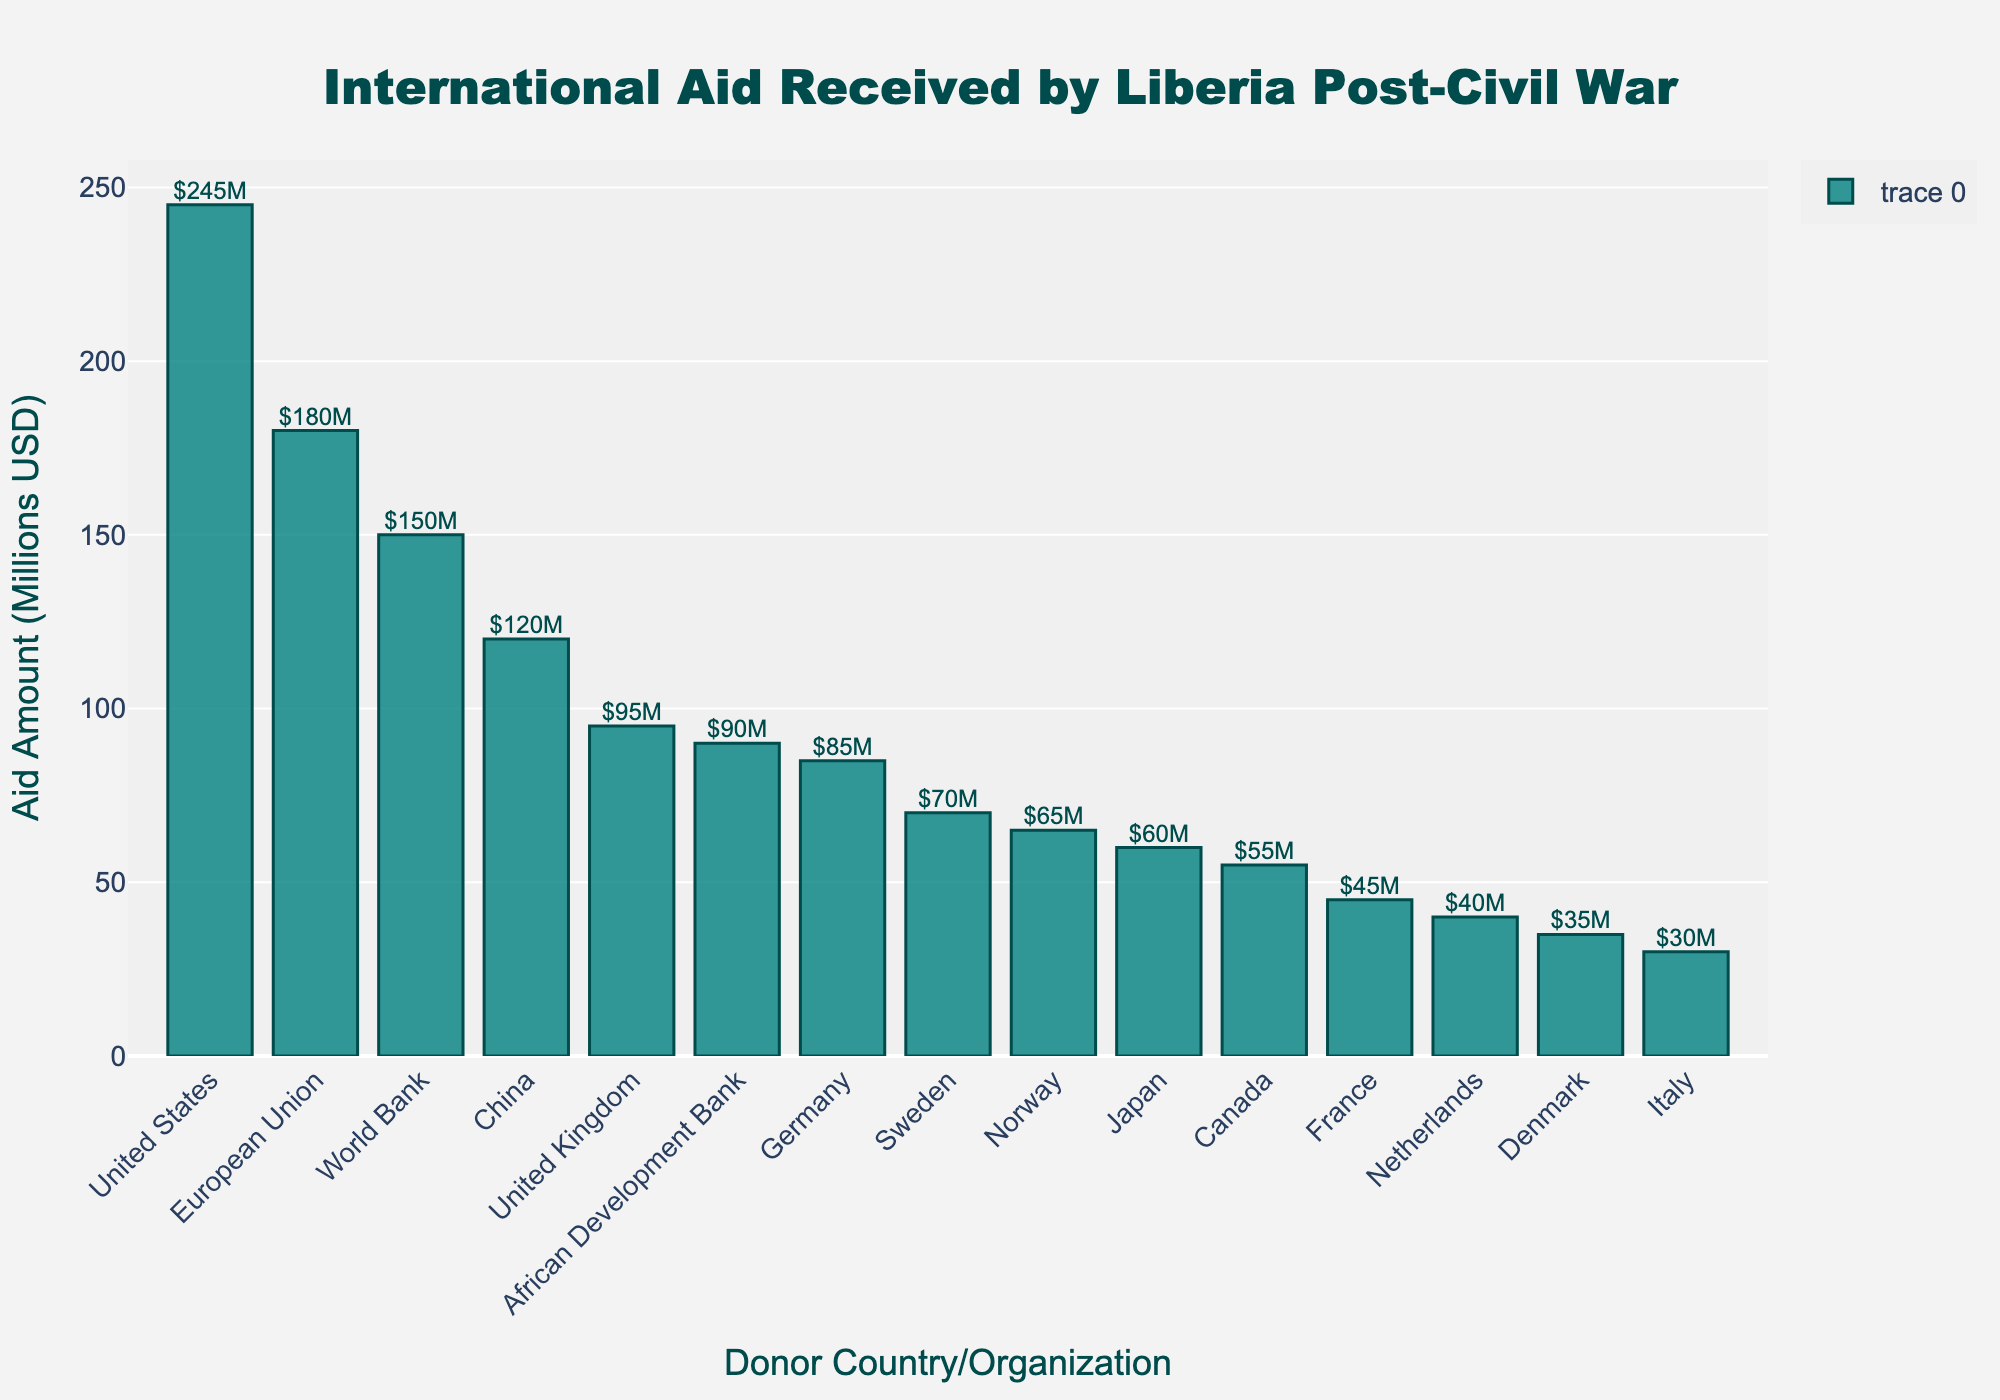Which country provided the largest amount of aid to Liberia? The bar with the highest length represents the largest amount, which is from the United States.
Answer: United States What is the total amount of aid received from the top three donor countries? The top three countries are the United States ($245M), the European Union ($180M), and the World Bank ($150M). Adding these amounts: 245 + 180 + 150 = $575M.
Answer: $575M Which donor provided more aid, China or Japan? By comparing the heights of the bars for China ($120M) and Japan ($60M), we can see that China provided more aid.
Answer: China What is the difference in aid between the United Kingdom and Germany? The aid amount from the United Kingdom is $95M, and Germany provided $85M. The difference is 95 - 85 = $10M.
Answer: $10M How much aid did the African Development Bank provide, and how does it compare visually to Italy? The African Development Bank provided $90M, which is represented by a taller bar compared to Italy's bar representing $30M.
Answer: $90M, taller than Italy Of the countries that provided aid less than $60M, which provided the most? The countries providing less than $60M are France ($45M), Netherlands ($40M), Denmark ($35M), and Italy ($30M). Among these, France provided the most.
Answer: France What is the total aid provided by Norway and Sweden combined? Norway provided $65M and Sweden provided $70M. Combined, this is 65 + 70 = $135M.
Answer: $135M Which organization provided more aid, the World Bank or the African Development Bank? The World Bank provided more aid ($150M) compared to the African Development Bank ($90M).
Answer: World Bank If we combine the aid from Germany and Canada, does it exceed the amount received from the World Bank? Germany provided $85M, and Canada provided $55M. Combined, this is 85 + 55 = $140M, which does not exceed the World Bank's $150M.
Answer: No What is the average aid amount provided by the European Union and France? The European Union provided $180M and France provided $45M. The average is calculated as (180 + 45) / 2 = $112.5M.
Answer: $112.5M 